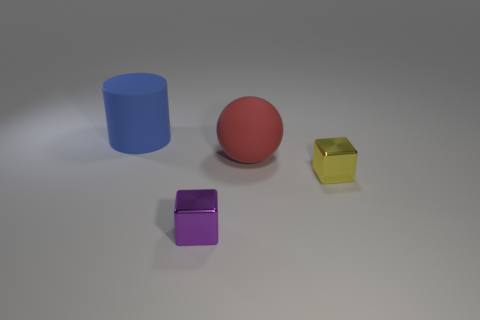Does the cylinder have the same material as the large object in front of the blue thing?
Give a very brief answer. Yes. The red thing that is the same material as the large cylinder is what size?
Make the answer very short. Large. Is the number of tiny metal blocks behind the purple thing greater than the number of blue objects left of the small yellow metallic object?
Offer a very short reply. No. Is there a matte thing that has the same shape as the purple metallic thing?
Provide a succinct answer. No. Is the size of the shiny block that is to the left of the red rubber object the same as the tiny yellow shiny block?
Your response must be concise. Yes. Are there any small purple shiny things?
Provide a succinct answer. Yes. How many things are large objects behind the red thing or large cylinders?
Make the answer very short. 1. There is a rubber cylinder; is it the same color as the small shiny cube in front of the yellow shiny block?
Offer a very short reply. No. Are there any cyan metal balls that have the same size as the purple metallic thing?
Provide a short and direct response. No. There is a yellow block on the right side of the big rubber thing that is to the right of the large blue cylinder; what is its material?
Provide a short and direct response. Metal. 